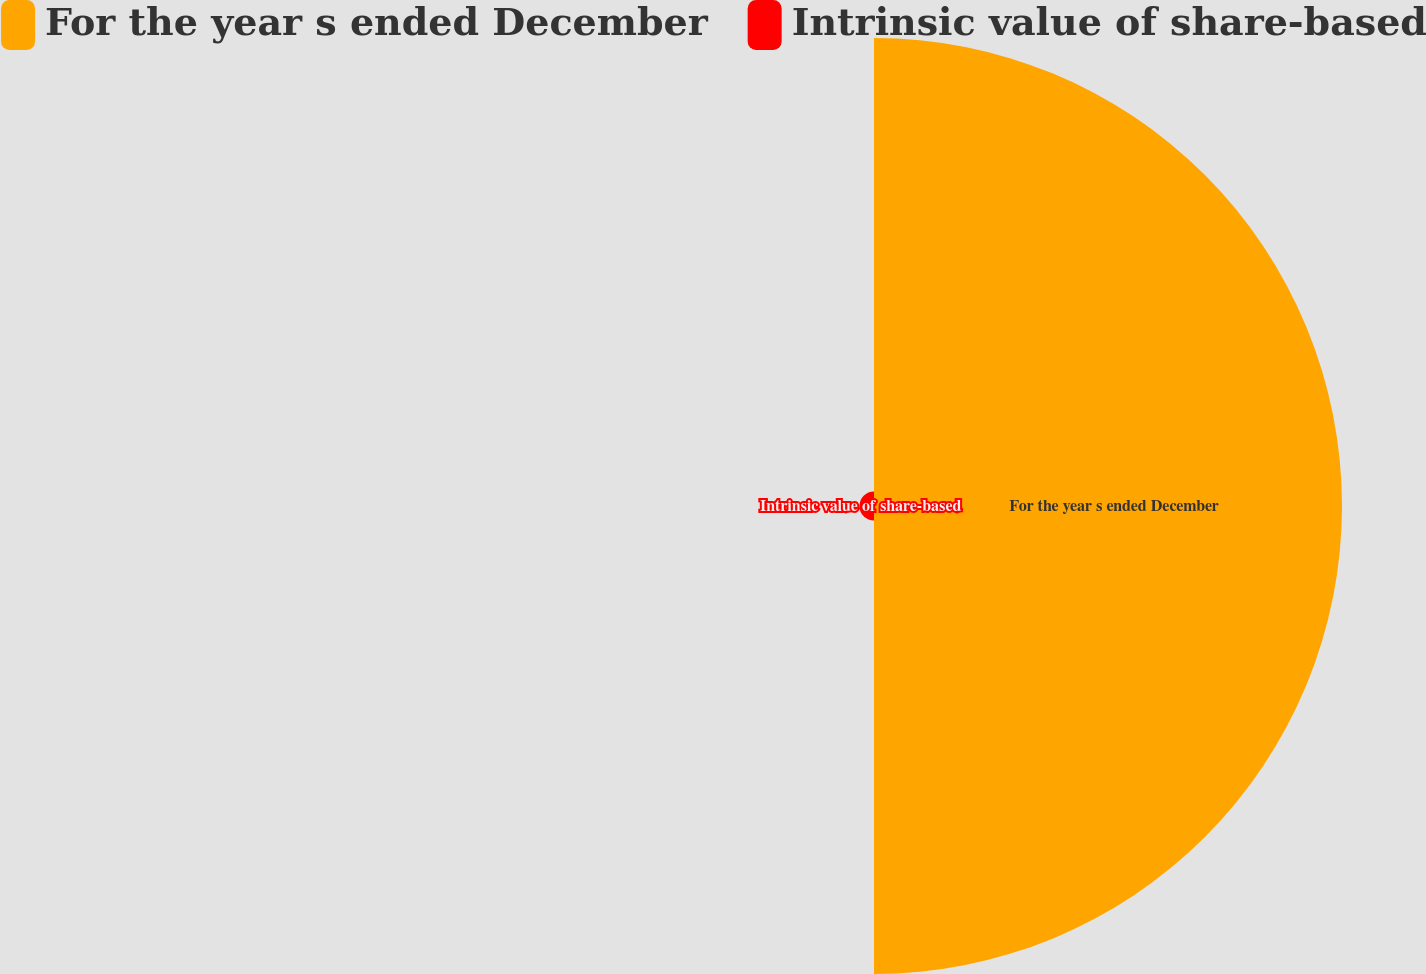Convert chart. <chart><loc_0><loc_0><loc_500><loc_500><pie_chart><fcel>For the year s ended December<fcel>Intrinsic value of share-based<nl><fcel>96.98%<fcel>3.02%<nl></chart> 